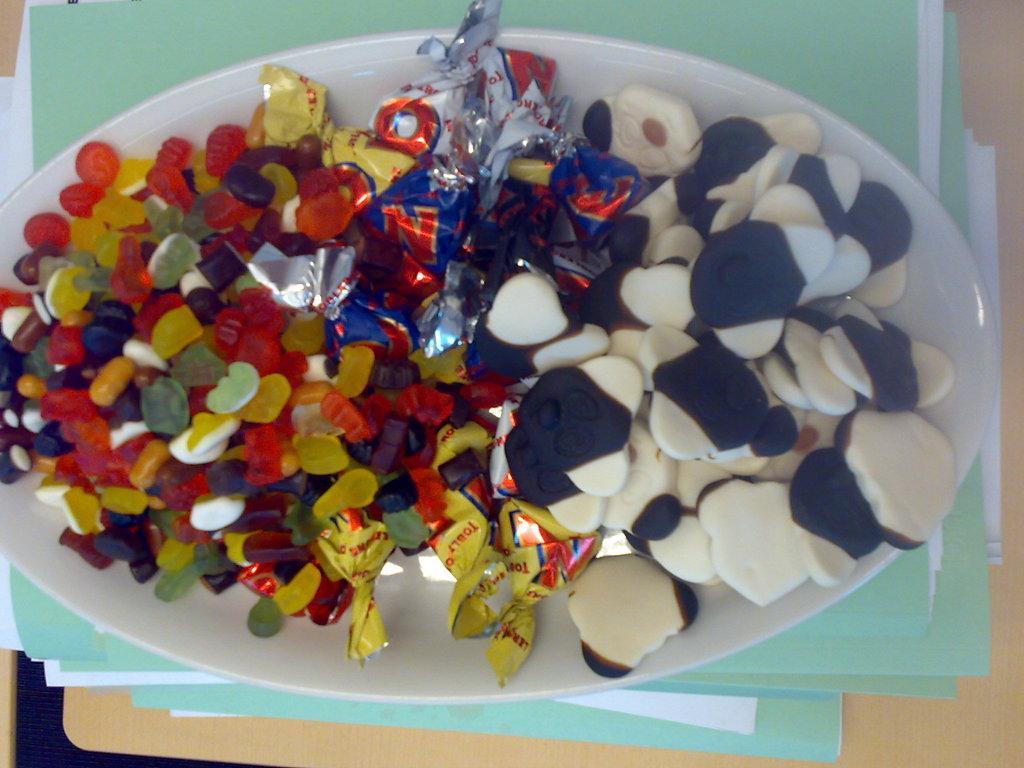Please provide a concise description of this image. In this image we can see some food on the plate. We can see a plate is placed on the files. We can see few files placed on the table. 